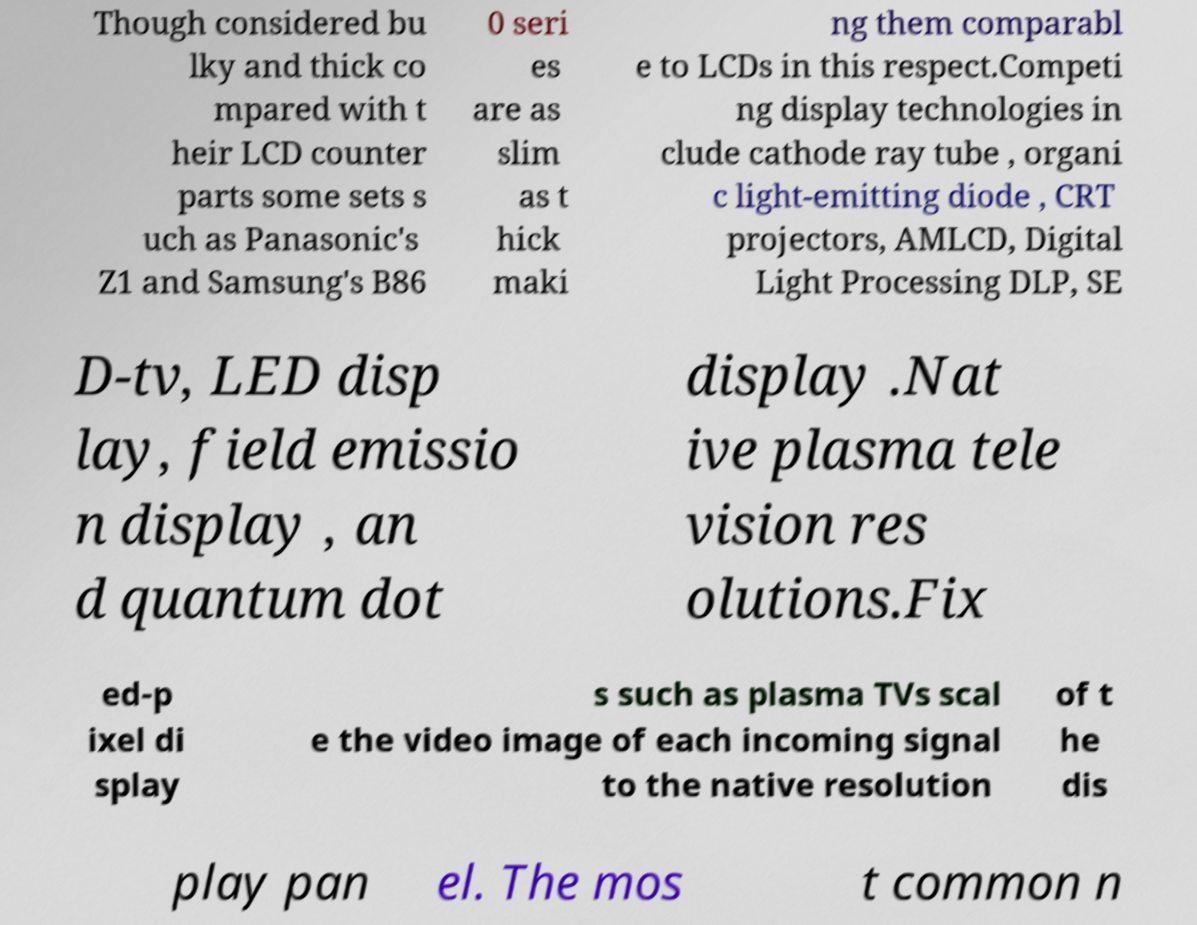I need the written content from this picture converted into text. Can you do that? Though considered bu lky and thick co mpared with t heir LCD counter parts some sets s uch as Panasonic's Z1 and Samsung's B86 0 seri es are as slim as t hick maki ng them comparabl e to LCDs in this respect.Competi ng display technologies in clude cathode ray tube , organi c light-emitting diode , CRT projectors, AMLCD, Digital Light Processing DLP, SE D-tv, LED disp lay, field emissio n display , an d quantum dot display .Nat ive plasma tele vision res olutions.Fix ed-p ixel di splay s such as plasma TVs scal e the video image of each incoming signal to the native resolution of t he dis play pan el. The mos t common n 